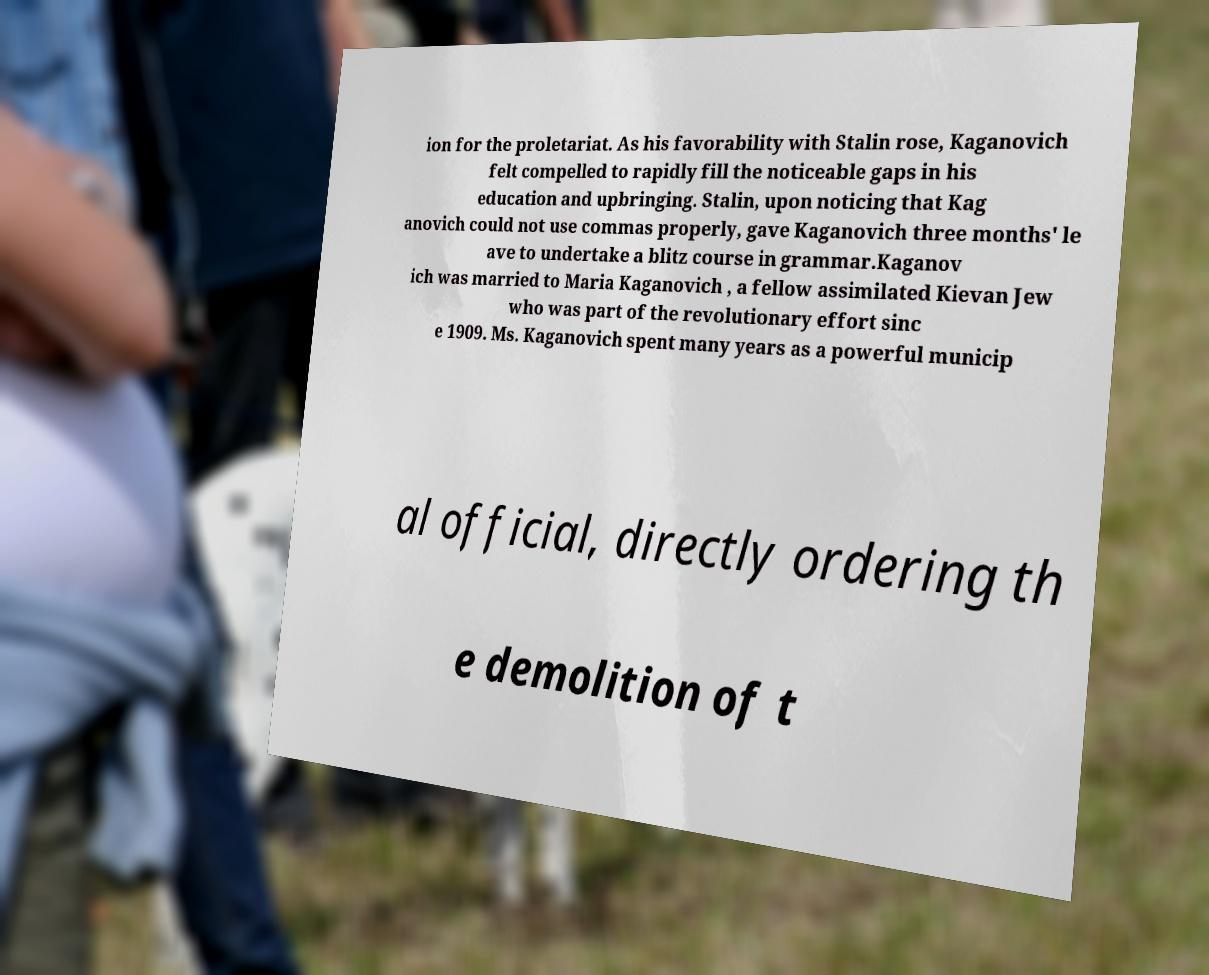What messages or text are displayed in this image? I need them in a readable, typed format. ion for the proletariat. As his favorability with Stalin rose, Kaganovich felt compelled to rapidly fill the noticeable gaps in his education and upbringing. Stalin, upon noticing that Kag anovich could not use commas properly, gave Kaganovich three months' le ave to undertake a blitz course in grammar.Kaganov ich was married to Maria Kaganovich , a fellow assimilated Kievan Jew who was part of the revolutionary effort sinc e 1909. Ms. Kaganovich spent many years as a powerful municip al official, directly ordering th e demolition of t 